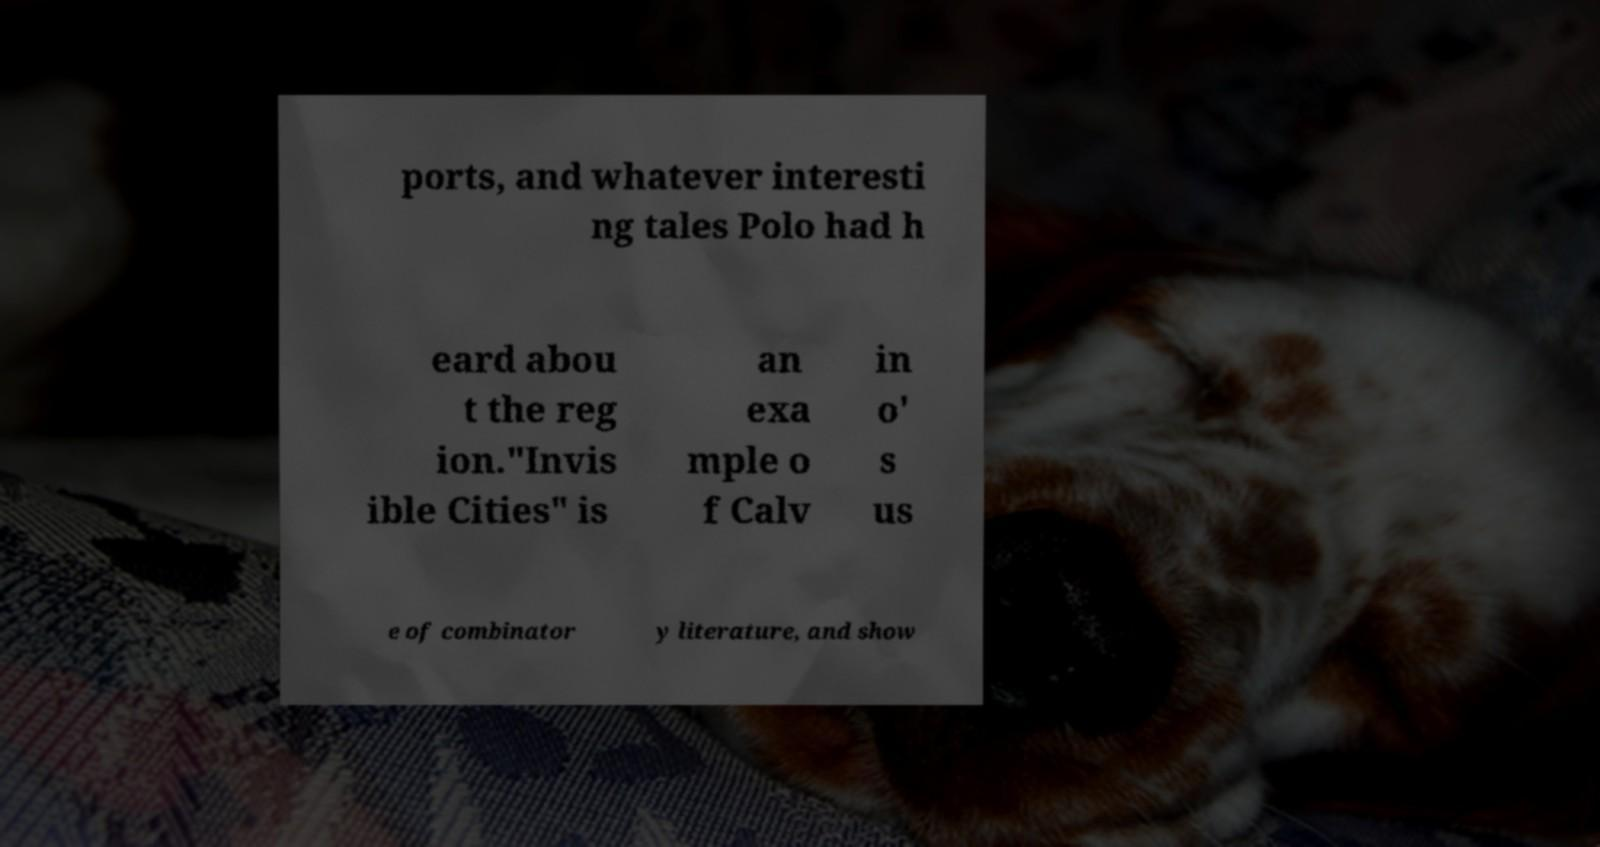I need the written content from this picture converted into text. Can you do that? ports, and whatever interesti ng tales Polo had h eard abou t the reg ion."Invis ible Cities" is an exa mple o f Calv in o' s us e of combinator y literature, and show 